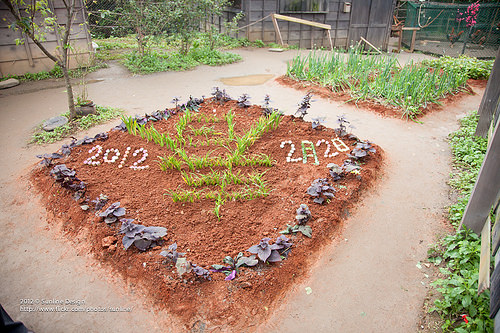<image>
Is the soil on the floor? Yes. Looking at the image, I can see the soil is positioned on top of the floor, with the floor providing support. 